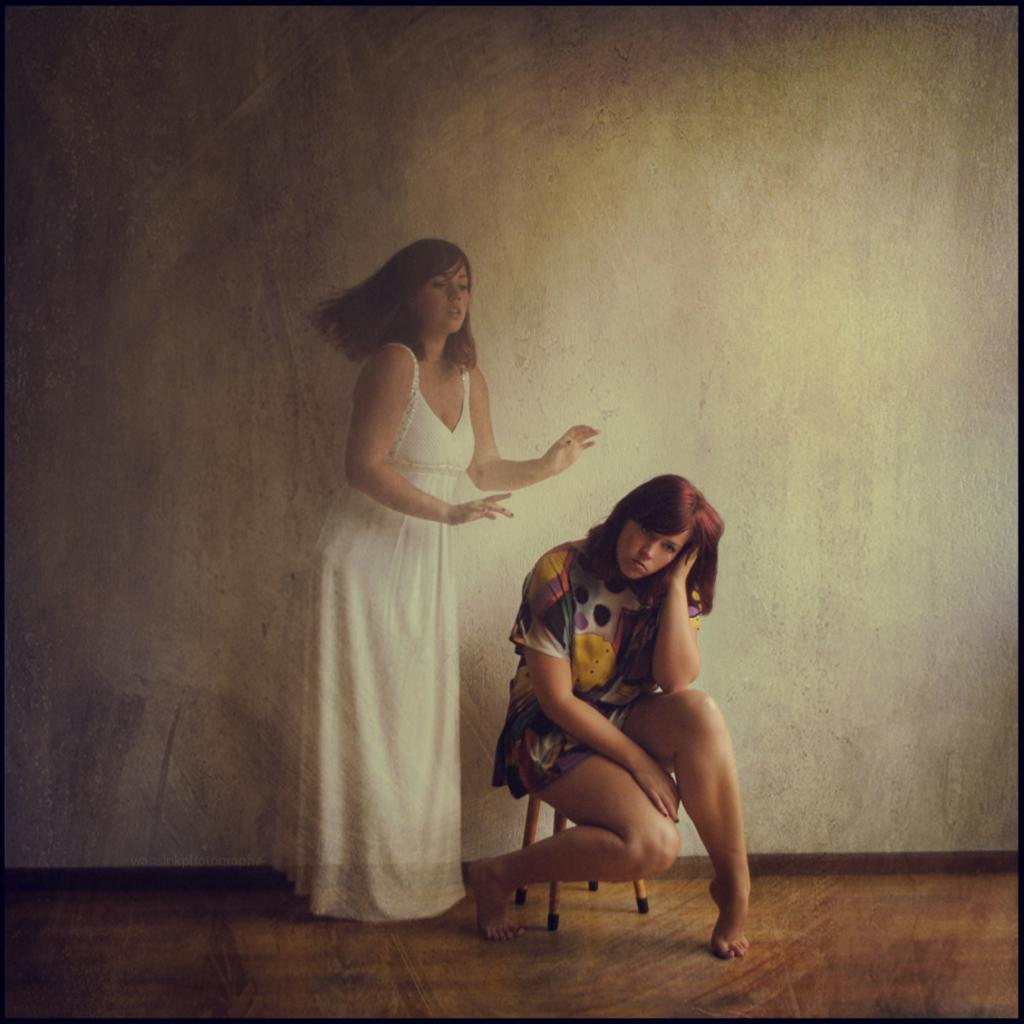How many women are in the image? There are two women in the image. What are the positions of the women in the image? One woman is standing, and the other woman is sitting. What is the standing woman wearing? The standing woman is wearing a white dress. What is the sitting woman wearing? The sitting woman is wearing a shirt. What can be seen in the background of the image? There is a wall in the background of the image. What type of string can be seen connecting the two women in the image? There is no string connecting the two women in the image. 